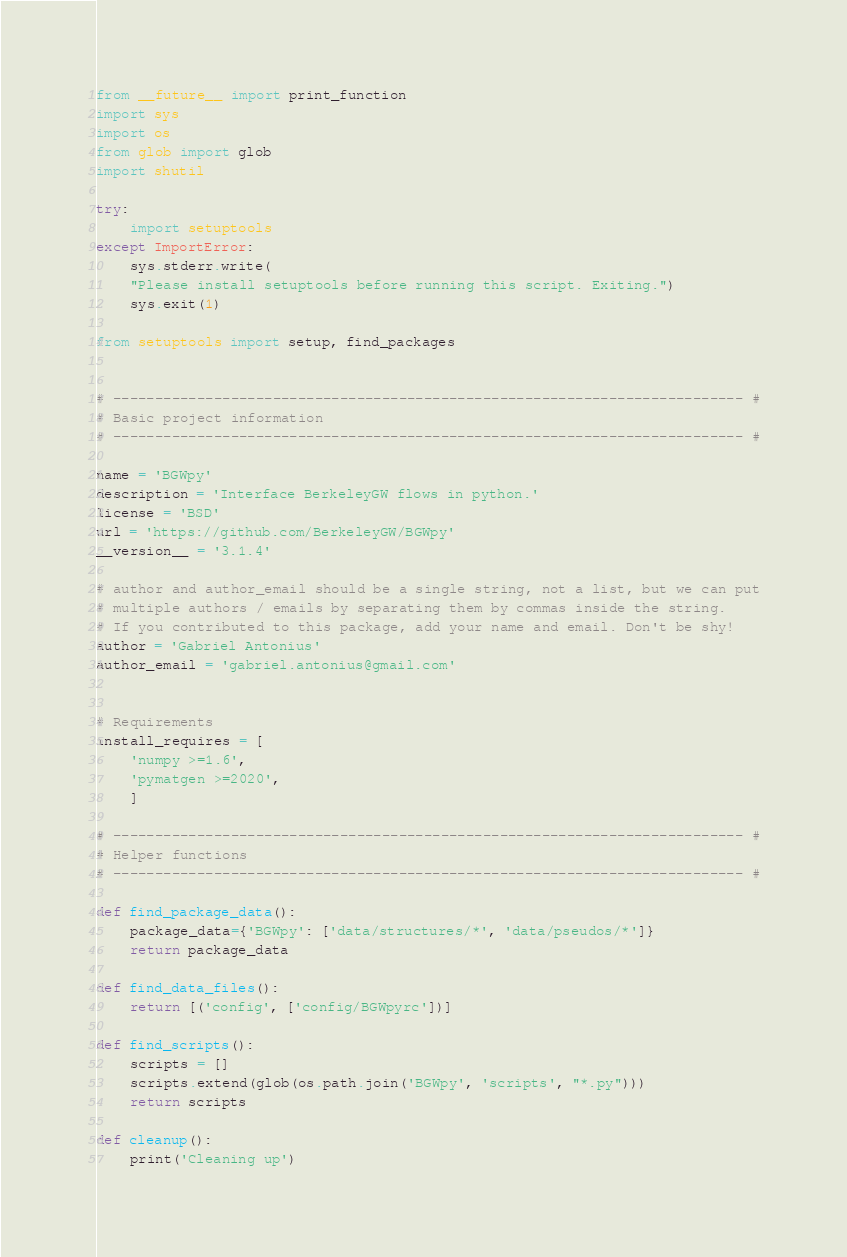Convert code to text. <code><loc_0><loc_0><loc_500><loc_500><_Python_>from __future__ import print_function
import sys
import os
from glob import glob
import shutil

try:
    import setuptools
except ImportError:
    sys.stderr.write(
    "Please install setuptools before running this script. Exiting.")
    sys.exit(1)

from setuptools import setup, find_packages


# --------------------------------------------------------------------------- #
# Basic project information
# --------------------------------------------------------------------------- #

name = 'BGWpy'
description = 'Interface BerkeleyGW flows in python.'
license = 'BSD'
url = 'https://github.com/BerkeleyGW/BGWpy'
__version__ = '3.1.4'

# author and author_email should be a single string, not a list, but we can put
# multiple authors / emails by separating them by commas inside the string.
# If you contributed to this package, add your name and email. Don't be shy!
author = 'Gabriel Antonius'
author_email = 'gabriel.antonius@gmail.com'


# Requirements
install_requires = [
    'numpy >=1.6',
    'pymatgen >=2020',
    ]

# --------------------------------------------------------------------------- #
# Helper functions
# --------------------------------------------------------------------------- #

def find_package_data():
    package_data={'BGWpy': ['data/structures/*', 'data/pseudos/*']}
    return package_data

def find_data_files():
    return [('config', ['config/BGWpyrc'])]

def find_scripts():
    scripts = []
    scripts.extend(glob(os.path.join('BGWpy', 'scripts', "*.py")))
    return scripts

def cleanup():
    print('Cleaning up')</code> 